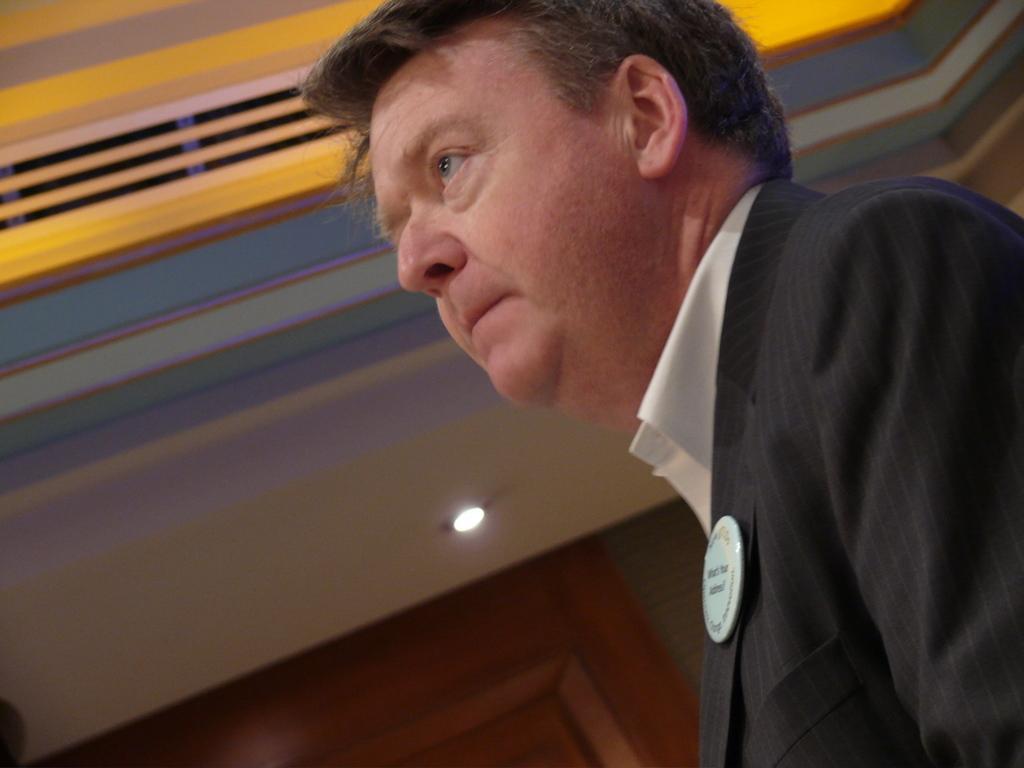Describe this image in one or two sentences. In this image in the foreground there is one person, and in the background there is a door, wall, light and at the top it looks like a ceiling. 